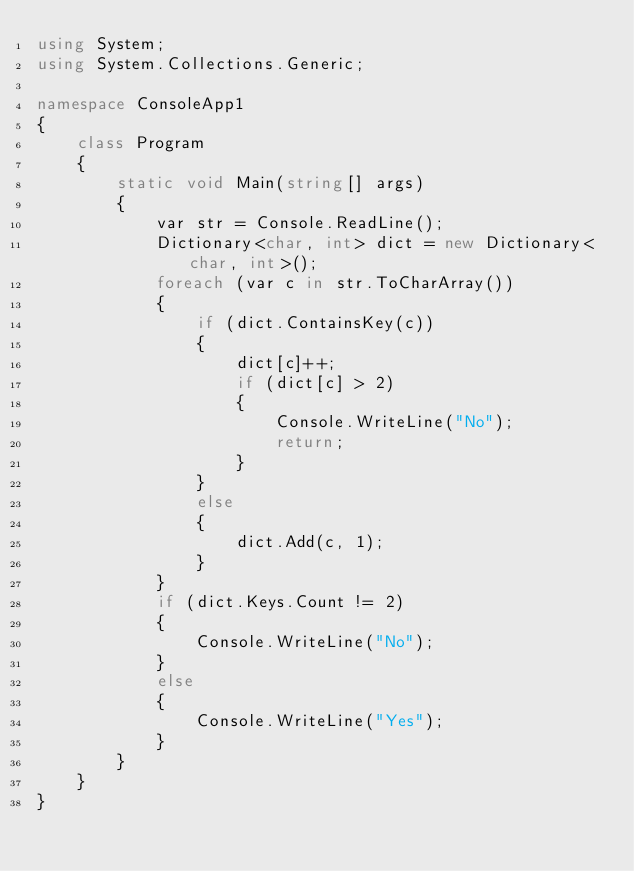<code> <loc_0><loc_0><loc_500><loc_500><_C#_>using System;
using System.Collections.Generic;

namespace ConsoleApp1
{
	class Program
	{
		static void Main(string[] args)
		{
			var str = Console.ReadLine();
			Dictionary<char, int> dict = new Dictionary<char, int>();
			foreach (var c in str.ToCharArray())
			{
				if (dict.ContainsKey(c))
				{
					dict[c]++;
					if (dict[c] > 2)
					{
						Console.WriteLine("No");
						return;
					}
				}
				else
				{
					dict.Add(c, 1);
				}
			}
			if (dict.Keys.Count != 2)
			{
				Console.WriteLine("No");
			}
			else
			{
				Console.WriteLine("Yes");
			}
		}
	}
}
</code> 